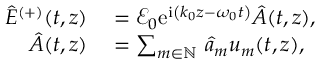<formula> <loc_0><loc_0><loc_500><loc_500>\begin{array} { r l } { \hat { E } ^ { ( + ) } ( t , z ) } & = \mathcal { E } _ { 0 } e ^ { i \left ( k _ { 0 } z - \omega _ { 0 } t \right ) } \hat { A } ( t , z ) , } \\ { \hat { A } ( t , z ) } & = \sum _ { m \in \mathbb { N } } \, \hat { a } _ { m } u _ { m } ( t , z ) , } \end{array}</formula> 